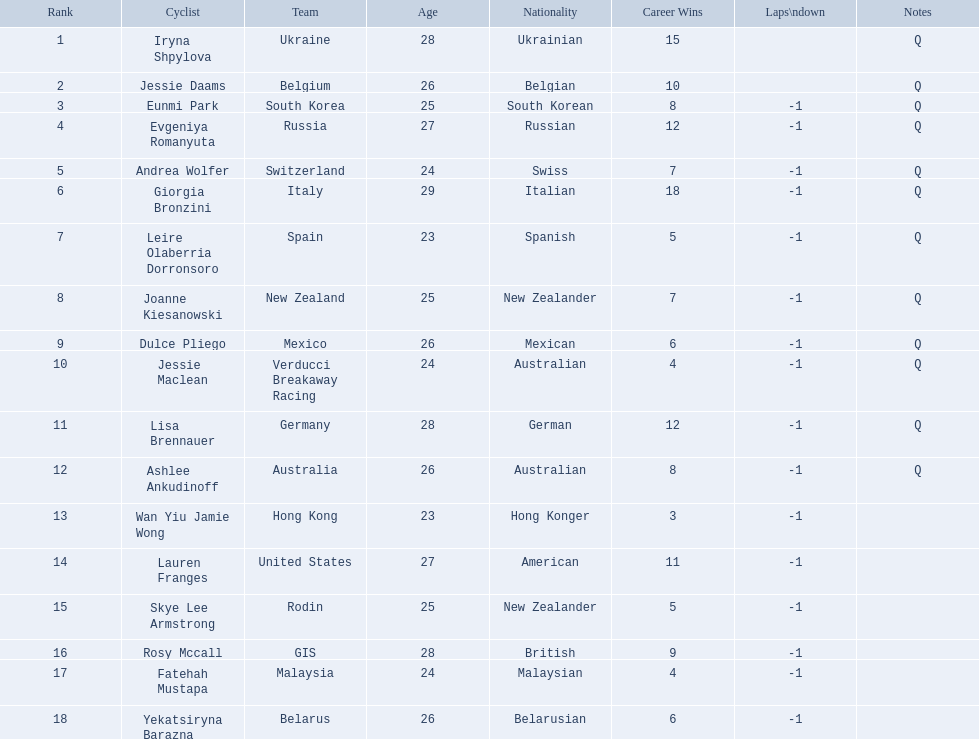Who are all of the cyclists in this race? Iryna Shpylova, Jessie Daams, Eunmi Park, Evgeniya Romanyuta, Andrea Wolfer, Giorgia Bronzini, Leire Olaberria Dorronsoro, Joanne Kiesanowski, Dulce Pliego, Jessie Maclean, Lisa Brennauer, Ashlee Ankudinoff, Wan Yiu Jamie Wong, Lauren Franges, Skye Lee Armstrong, Rosy Mccall, Fatehah Mustapa, Yekatsiryna Barazna. I'm looking to parse the entire table for insights. Could you assist me with that? {'header': ['Rank', 'Cyclist', 'Team', 'Age', 'Nationality', 'Career Wins', 'Laps\\ndown', 'Notes'], 'rows': [['1', 'Iryna Shpylova', 'Ukraine', '28', 'Ukrainian', '15', '', 'Q'], ['2', 'Jessie Daams', 'Belgium', '26', 'Belgian', '10', '', 'Q'], ['3', 'Eunmi Park', 'South Korea', '25', 'South Korean', '8', '-1', 'Q'], ['4', 'Evgeniya Romanyuta', 'Russia', '27', 'Russian', '12', '-1', 'Q'], ['5', 'Andrea Wolfer', 'Switzerland', '24', 'Swiss', '7', '-1', 'Q'], ['6', 'Giorgia Bronzini', 'Italy', '29', 'Italian', '18', '-1', 'Q'], ['7', 'Leire Olaberria Dorronsoro', 'Spain', '23', 'Spanish', '5', '-1', 'Q'], ['8', 'Joanne Kiesanowski', 'New Zealand', '25', 'New Zealander', '7', '-1', 'Q'], ['9', 'Dulce Pliego', 'Mexico', '26', 'Mexican', '6', '-1', 'Q'], ['10', 'Jessie Maclean', 'Verducci Breakaway Racing', '24', 'Australian', '4', '-1', 'Q'], ['11', 'Lisa Brennauer', 'Germany', '28', 'German', '12', '-1', 'Q'], ['12', 'Ashlee Ankudinoff', 'Australia', '26', 'Australian', '8', '-1', 'Q'], ['13', 'Wan Yiu Jamie Wong', 'Hong Kong', '23', 'Hong Konger', '3', '-1', ''], ['14', 'Lauren Franges', 'United States', '27', 'American', '11', '-1', ''], ['15', 'Skye Lee Armstrong', 'Rodin', '25', 'New Zealander', '5', '-1', ''], ['16', 'Rosy Mccall', 'GIS', '28', 'British', '9', '-1', ''], ['17', 'Fatehah Mustapa', 'Malaysia', '24', 'Malaysian', '4', '-1', ''], ['18', 'Yekatsiryna Barazna', 'Belarus', '26', 'Belarusian', '6', '-1', '']]} Of these, which one has the lowest numbered rank? Iryna Shpylova. 